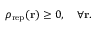<formula> <loc_0><loc_0><loc_500><loc_500>\rho _ { r e p } ( { r } ) \geq 0 , \quad \forall { r } .</formula> 